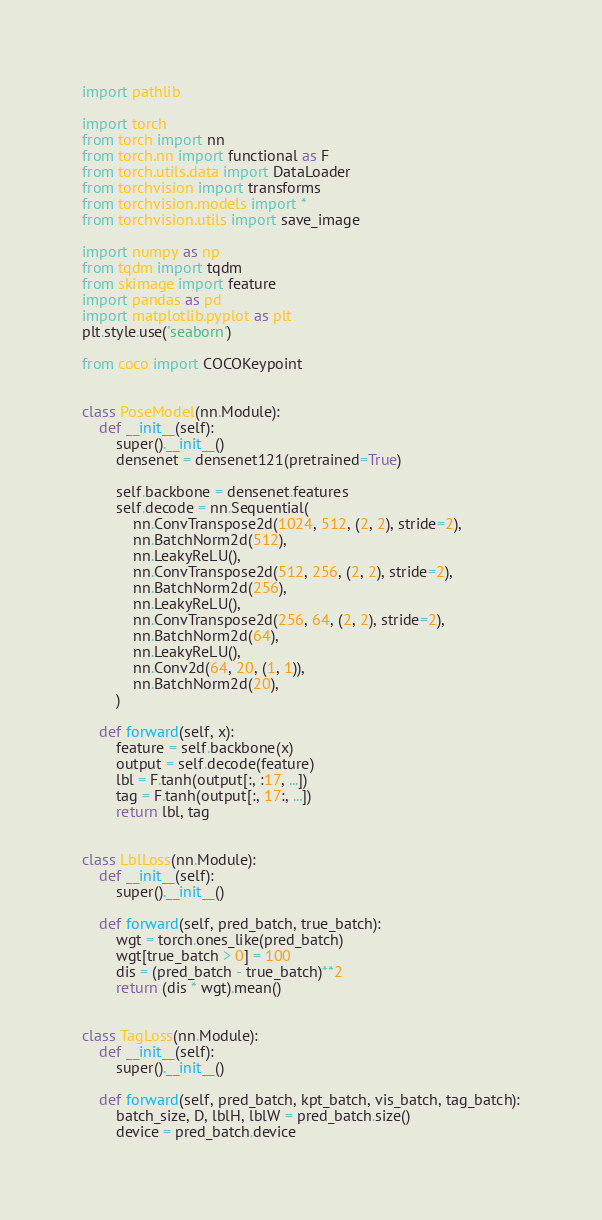<code> <loc_0><loc_0><loc_500><loc_500><_Python_>import pathlib

import torch
from torch import nn
from torch.nn import functional as F
from torch.utils.data import DataLoader
from torchvision import transforms
from torchvision.models import *
from torchvision.utils import save_image

import numpy as np
from tqdm import tqdm
from skimage import feature
import pandas as pd
import matplotlib.pyplot as plt
plt.style.use('seaborn')

from coco import COCOKeypoint


class PoseModel(nn.Module):
    def __init__(self):
        super().__init__()
        densenet = densenet121(pretrained=True)

        self.backbone = densenet.features
        self.decode = nn.Sequential(
            nn.ConvTranspose2d(1024, 512, (2, 2), stride=2),
            nn.BatchNorm2d(512),
            nn.LeakyReLU(),
            nn.ConvTranspose2d(512, 256, (2, 2), stride=2),
            nn.BatchNorm2d(256),
            nn.LeakyReLU(),
            nn.ConvTranspose2d(256, 64, (2, 2), stride=2),
            nn.BatchNorm2d(64),
            nn.LeakyReLU(),
            nn.Conv2d(64, 20, (1, 1)),
            nn.BatchNorm2d(20),
        )

    def forward(self, x):
        feature = self.backbone(x)
        output = self.decode(feature)
        lbl = F.tanh(output[:, :17, ...])
        tag = F.tanh(output[:, 17:, ...])
        return lbl, tag


class LblLoss(nn.Module):
    def __init__(self):
        super().__init__()

    def forward(self, pred_batch, true_batch):
        wgt = torch.ones_like(pred_batch)
        wgt[true_batch > 0] = 100
        dis = (pred_batch - true_batch)**2
        return (dis * wgt).mean()


class TagLoss(nn.Module):
    def __init__(self):
        super().__init__()

    def forward(self, pred_batch, kpt_batch, vis_batch, tag_batch):
        batch_size, D, lblH, lblW = pred_batch.size()
        device = pred_batch.device</code> 